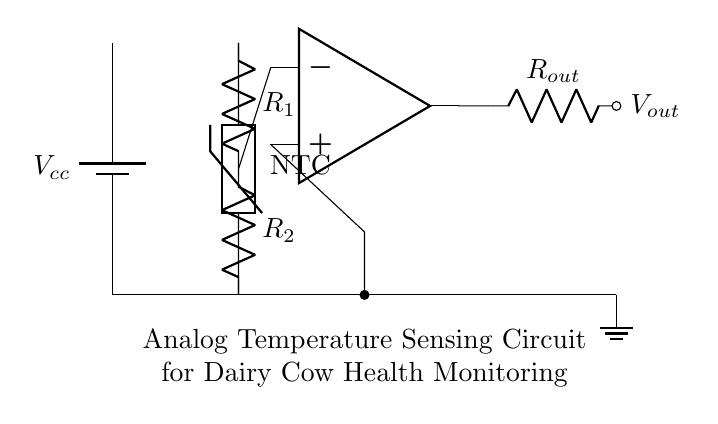What type of sensor is used in this circuit? The circuit diagram includes a thermistor, which is labeled as NTC (Negative Temperature Coefficient), indicating it’s used for temperature sensing.
Answer: thermistor What is the configuration of the resistors in this circuit? The diagram shows a voltage divider configuration consisting of two resistors connected in series, where one resistor is connected to the thermistor and the output of the voltage is taken from the junction of the two resistors.
Answer: voltage divider How is the output voltage represented in this circuit? The output voltage is represented by the node labeled as Vout, which is connected to a resistor labeled as Rout, indicating that it is the output from the op-amp circuitry designed for amplification based on the input from the voltage divider.
Answer: Vout What is the primary function of the op-amp in this circuit? The op-amp amplifies the voltage difference between its non-inverting and inverting inputs, which in this case processes the voltage signal from the voltage divider formed by the thermistor and resistors to provide a scaled output voltage representative of temperature changes.
Answer: amplification Which component provides the power supply for the circuit? The power supply is provided by a battery, denoted as Vcc, which is at the top of the circuit diagram and connected to the components to power the circuit.
Answer: battery What happens to the output voltage as the temperature increases? The output voltage is likely to increase because as the temperature rises, the resistance of the NTC thermistor decreases, which in turn changes the voltage divider ratio, effectively sending a higher voltage to the op-amp input for amplification.
Answer: increases What does NTC stand for regarding the thermistor? NTC stands for Negative Temperature Coefficient, indicating that the resistance of the thermistor decreases as the temperature increases, which is crucial for accurate temperature measurement in this monitoring circuit.
Answer: Negative Temperature Coefficient 